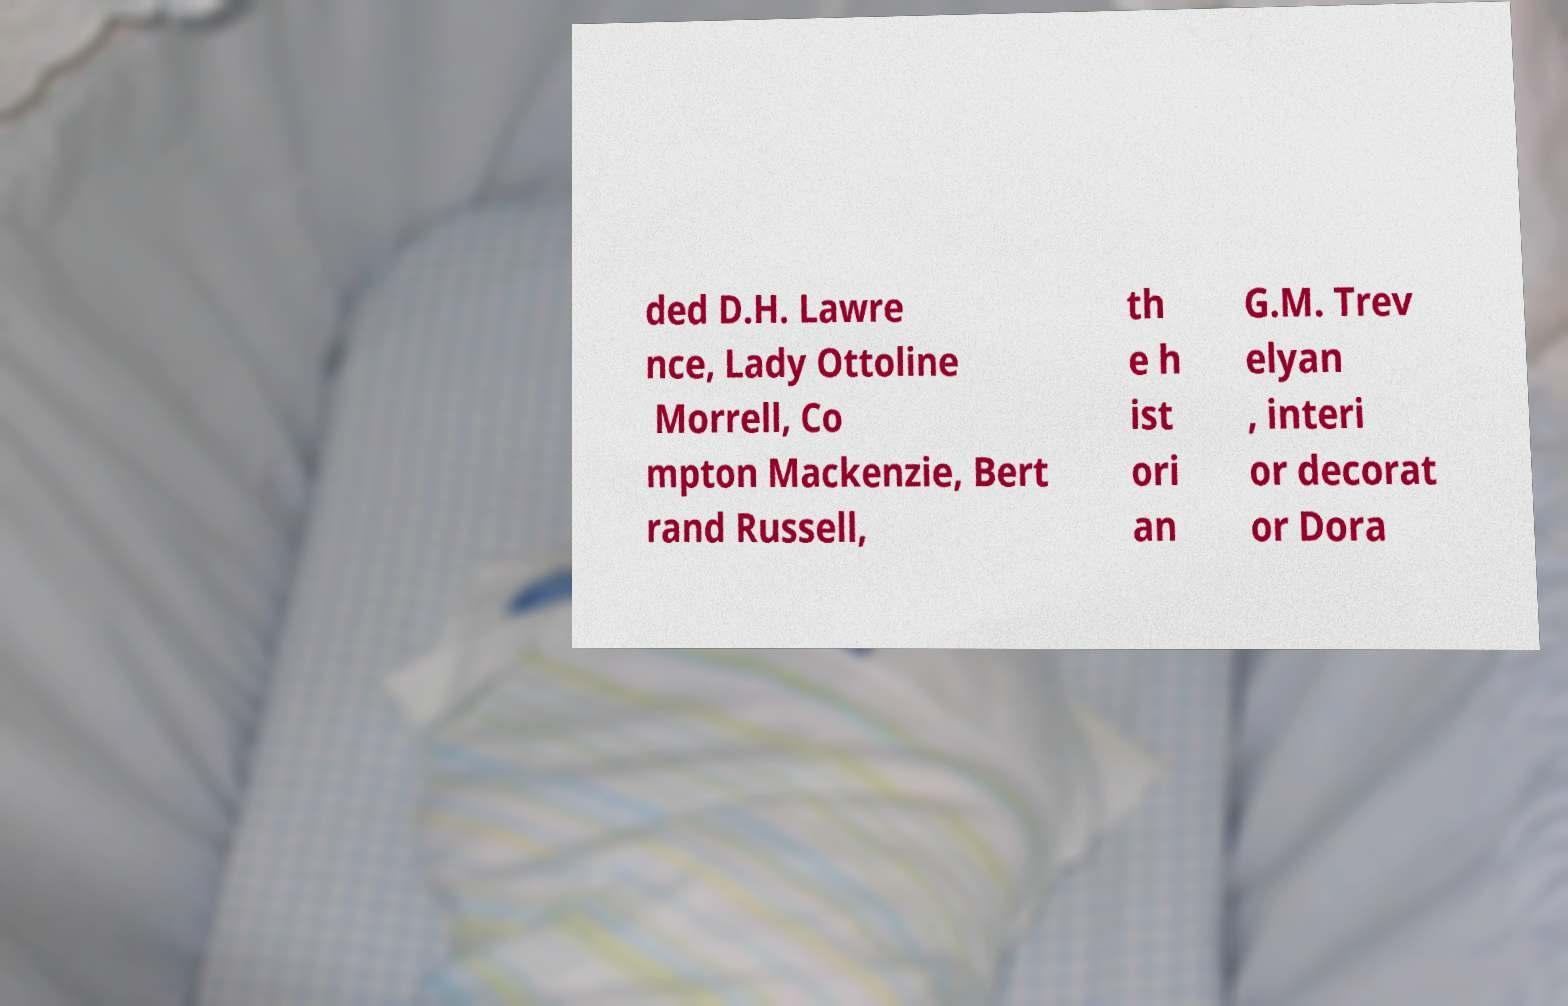What messages or text are displayed in this image? I need them in a readable, typed format. ded D.H. Lawre nce, Lady Ottoline Morrell, Co mpton Mackenzie, Bert rand Russell, th e h ist ori an G.M. Trev elyan , interi or decorat or Dora 